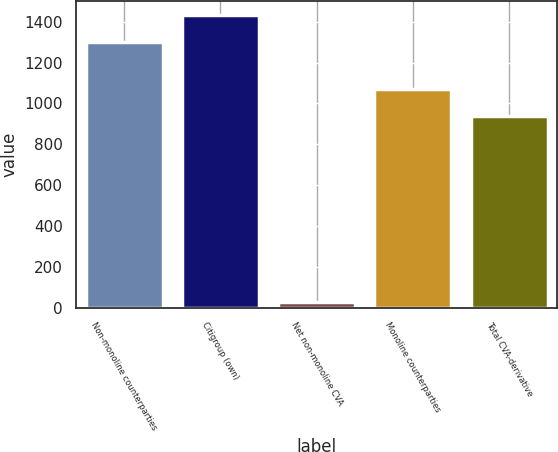Convert chart to OTSL. <chart><loc_0><loc_0><loc_500><loc_500><bar_chart><fcel>Non-monoline counterparties<fcel>Citigroup (own)<fcel>Net non-monoline CVA<fcel>Monoline counterparties<fcel>Total CVA-derivative<nl><fcel>1301<fcel>1431.1<fcel>28<fcel>1069.1<fcel>939<nl></chart> 